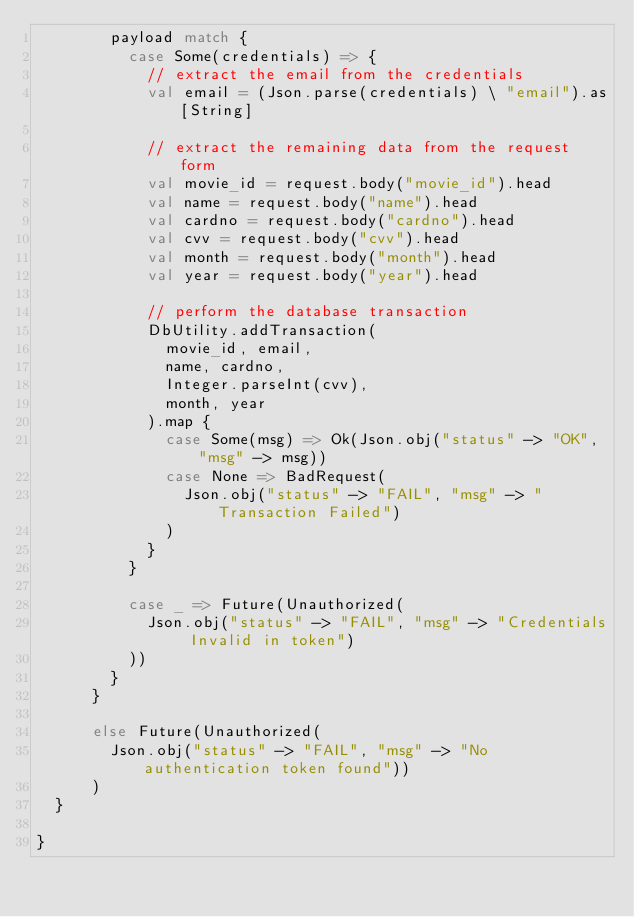Convert code to text. <code><loc_0><loc_0><loc_500><loc_500><_Scala_>        payload match {
          case Some(credentials) => {
            // extract the email from the credentials
            val email = (Json.parse(credentials) \ "email").as[String]

            // extract the remaining data from the request form
            val movie_id = request.body("movie_id").head
            val name = request.body("name").head
            val cardno = request.body("cardno").head
            val cvv = request.body("cvv").head
            val month = request.body("month").head
            val year = request.body("year").head

            // perform the database transaction
            DbUtility.addTransaction(
              movie_id, email,
              name, cardno,
              Integer.parseInt(cvv),
              month, year
            ).map {
              case Some(msg) => Ok(Json.obj("status" -> "OK", "msg" -> msg))
              case None => BadRequest(
                Json.obj("status" -> "FAIL", "msg" -> "Transaction Failed")
              )
            }
          }

          case _ => Future(Unauthorized(
            Json.obj("status" -> "FAIL", "msg" -> "Credentials Invalid in token")
          ))
        }
      }

      else Future(Unauthorized(
        Json.obj("status" -> "FAIL", "msg" -> "No authentication token found"))
      )
  }

}
</code> 